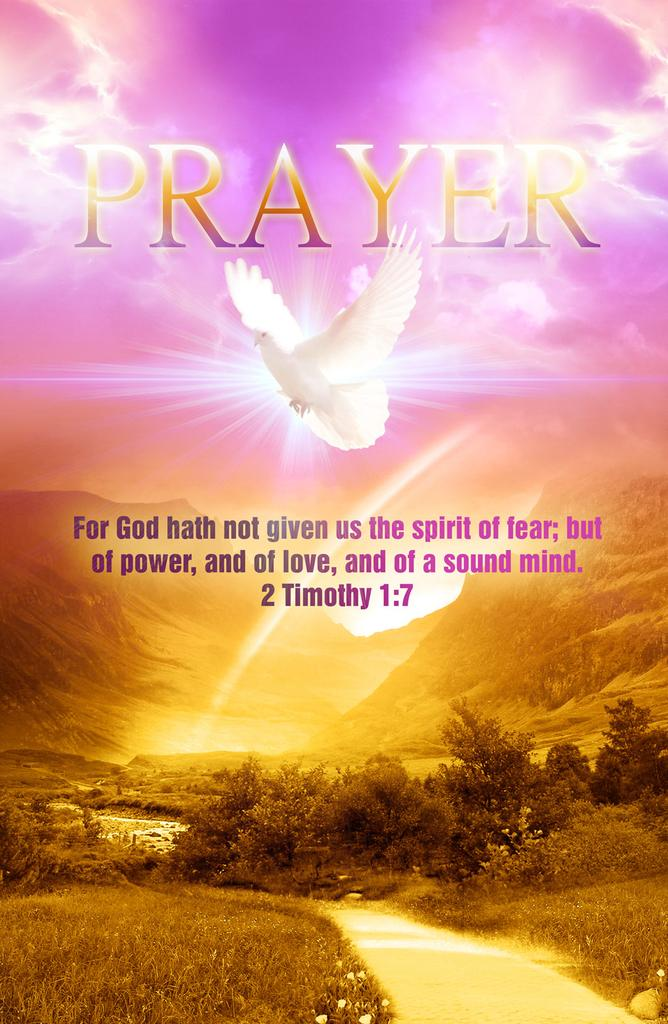<image>
Relay a brief, clear account of the picture shown. A religious poster with a dove on it that says "Prayer." 